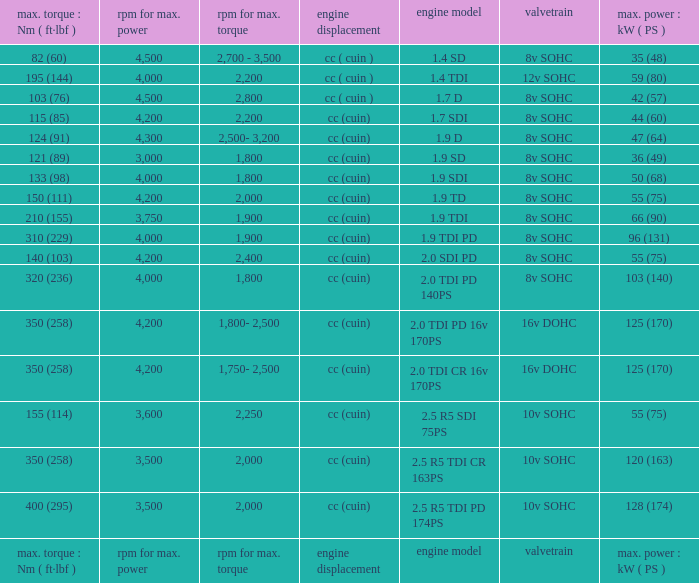What is the valvetrain with an engine model that is engine model? Valvetrain. 